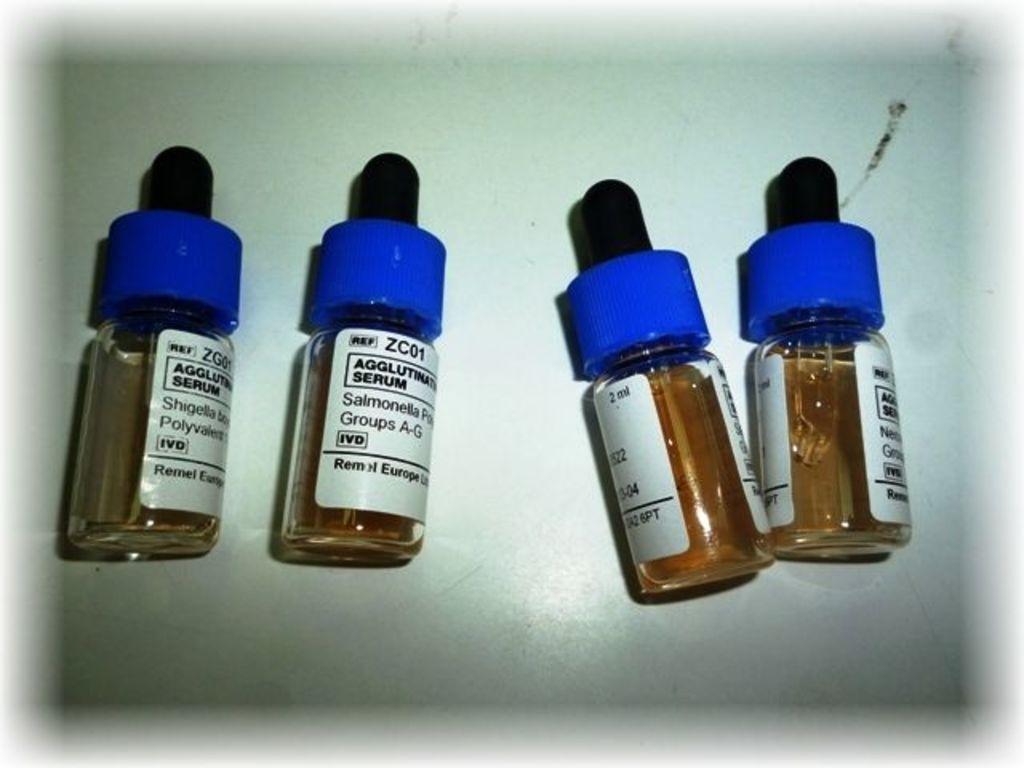What groups are in the second vial from the left?
Offer a very short reply. A-g. What is the code at the top of the label on the second bottle from the left?
Keep it short and to the point. Zc01. 